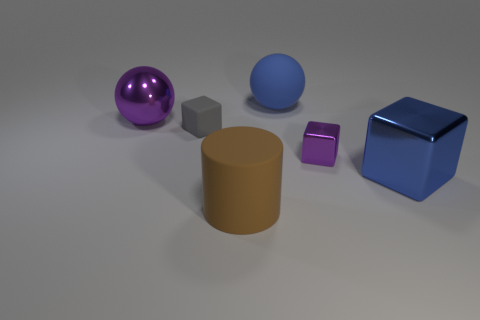There is a large cube that is the same material as the purple ball; what color is it?
Your response must be concise. Blue. Is the number of cubes on the left side of the brown matte object the same as the number of brown objects?
Offer a terse response. Yes. Is the size of the purple metallic object on the left side of the brown matte object the same as the blue cube?
Provide a short and direct response. Yes. The cylinder that is the same size as the blue metal object is what color?
Your answer should be compact. Brown. Is there a large matte cylinder that is on the left side of the block that is left of the big rubber object that is in front of the big blue block?
Offer a very short reply. No. There is a big object in front of the large blue block; what material is it?
Offer a very short reply. Rubber. Do the tiny purple thing and the big metal object on the left side of the big brown object have the same shape?
Your answer should be very brief. No. Are there an equal number of blue rubber balls left of the gray matte object and rubber spheres that are left of the big brown thing?
Offer a very short reply. Yes. How many other things are made of the same material as the tiny purple cube?
Provide a short and direct response. 2. What number of matte objects are big gray cylinders or large brown things?
Provide a short and direct response. 1. 